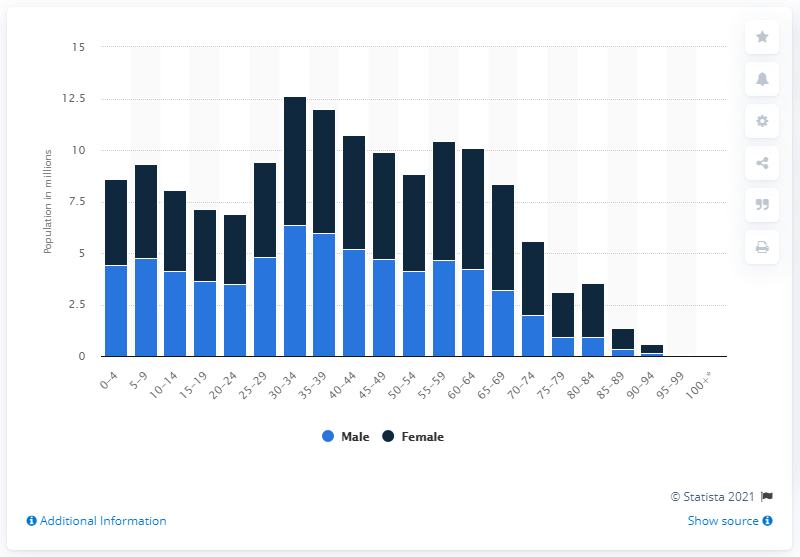Specify some key components in this picture. There were 6,360,000 men between the ages of 30 and 34 in Russia. 